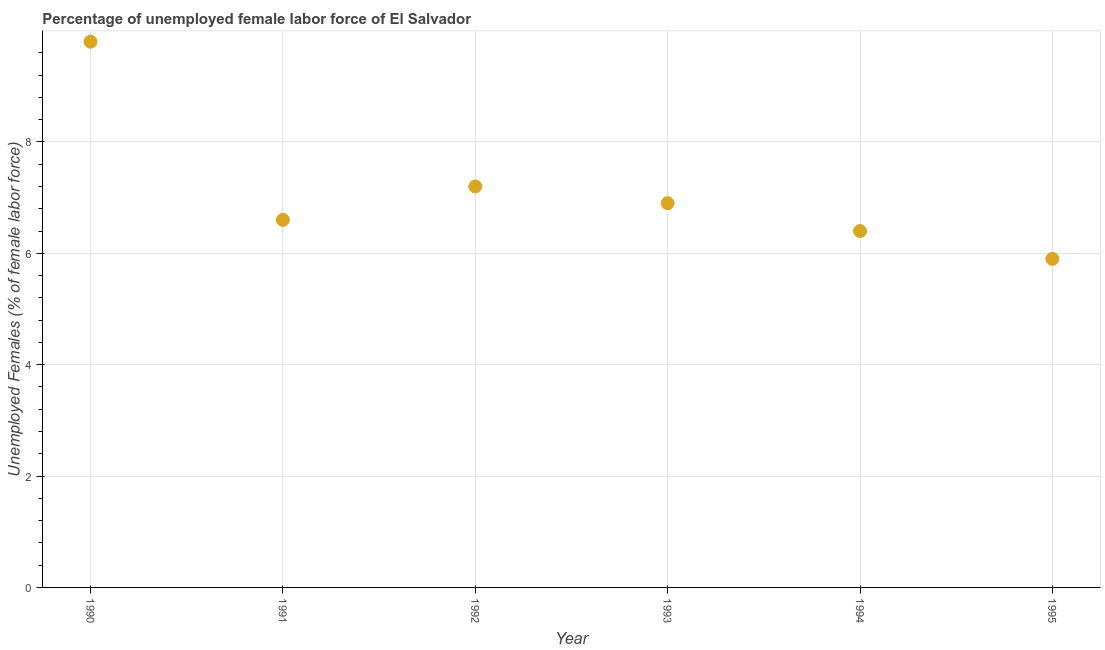What is the total unemployed female labour force in 1991?
Give a very brief answer. 6.6. Across all years, what is the maximum total unemployed female labour force?
Offer a terse response. 9.8. Across all years, what is the minimum total unemployed female labour force?
Offer a very short reply. 5.9. In which year was the total unemployed female labour force maximum?
Offer a terse response. 1990. What is the sum of the total unemployed female labour force?
Make the answer very short. 42.8. What is the difference between the total unemployed female labour force in 1990 and 1991?
Make the answer very short. 3.2. What is the average total unemployed female labour force per year?
Ensure brevity in your answer.  7.13. What is the median total unemployed female labour force?
Your answer should be compact. 6.75. In how many years, is the total unemployed female labour force greater than 4 %?
Make the answer very short. 6. Do a majority of the years between 1995 and 1992 (inclusive) have total unemployed female labour force greater than 0.4 %?
Make the answer very short. Yes. What is the ratio of the total unemployed female labour force in 1993 to that in 1995?
Give a very brief answer. 1.17. Is the total unemployed female labour force in 1992 less than that in 1994?
Keep it short and to the point. No. What is the difference between the highest and the second highest total unemployed female labour force?
Provide a succinct answer. 2.6. Is the sum of the total unemployed female labour force in 1990 and 1992 greater than the maximum total unemployed female labour force across all years?
Provide a short and direct response. Yes. What is the difference between the highest and the lowest total unemployed female labour force?
Give a very brief answer. 3.9. Does the total unemployed female labour force monotonically increase over the years?
Provide a short and direct response. No. How many years are there in the graph?
Offer a terse response. 6. Are the values on the major ticks of Y-axis written in scientific E-notation?
Offer a terse response. No. Does the graph contain any zero values?
Keep it short and to the point. No. What is the title of the graph?
Offer a very short reply. Percentage of unemployed female labor force of El Salvador. What is the label or title of the Y-axis?
Your response must be concise. Unemployed Females (% of female labor force). What is the Unemployed Females (% of female labor force) in 1990?
Your answer should be very brief. 9.8. What is the Unemployed Females (% of female labor force) in 1991?
Provide a succinct answer. 6.6. What is the Unemployed Females (% of female labor force) in 1992?
Your response must be concise. 7.2. What is the Unemployed Females (% of female labor force) in 1993?
Your response must be concise. 6.9. What is the Unemployed Females (% of female labor force) in 1994?
Provide a succinct answer. 6.4. What is the Unemployed Females (% of female labor force) in 1995?
Provide a short and direct response. 5.9. What is the difference between the Unemployed Females (% of female labor force) in 1990 and 1991?
Keep it short and to the point. 3.2. What is the difference between the Unemployed Females (% of female labor force) in 1990 and 1992?
Your answer should be compact. 2.6. What is the difference between the Unemployed Females (% of female labor force) in 1990 and 1993?
Your answer should be very brief. 2.9. What is the difference between the Unemployed Females (% of female labor force) in 1990 and 1994?
Your response must be concise. 3.4. What is the difference between the Unemployed Females (% of female labor force) in 1991 and 1994?
Offer a terse response. 0.2. What is the difference between the Unemployed Females (% of female labor force) in 1992 and 1993?
Your answer should be very brief. 0.3. What is the difference between the Unemployed Females (% of female labor force) in 1993 and 1994?
Your response must be concise. 0.5. What is the difference between the Unemployed Females (% of female labor force) in 1993 and 1995?
Your response must be concise. 1. What is the ratio of the Unemployed Females (% of female labor force) in 1990 to that in 1991?
Your answer should be compact. 1.49. What is the ratio of the Unemployed Females (% of female labor force) in 1990 to that in 1992?
Ensure brevity in your answer.  1.36. What is the ratio of the Unemployed Females (% of female labor force) in 1990 to that in 1993?
Offer a very short reply. 1.42. What is the ratio of the Unemployed Females (% of female labor force) in 1990 to that in 1994?
Keep it short and to the point. 1.53. What is the ratio of the Unemployed Females (% of female labor force) in 1990 to that in 1995?
Offer a very short reply. 1.66. What is the ratio of the Unemployed Females (% of female labor force) in 1991 to that in 1992?
Make the answer very short. 0.92. What is the ratio of the Unemployed Females (% of female labor force) in 1991 to that in 1994?
Ensure brevity in your answer.  1.03. What is the ratio of the Unemployed Females (% of female labor force) in 1991 to that in 1995?
Keep it short and to the point. 1.12. What is the ratio of the Unemployed Females (% of female labor force) in 1992 to that in 1993?
Offer a very short reply. 1.04. What is the ratio of the Unemployed Females (% of female labor force) in 1992 to that in 1994?
Make the answer very short. 1.12. What is the ratio of the Unemployed Females (% of female labor force) in 1992 to that in 1995?
Your response must be concise. 1.22. What is the ratio of the Unemployed Females (% of female labor force) in 1993 to that in 1994?
Give a very brief answer. 1.08. What is the ratio of the Unemployed Females (% of female labor force) in 1993 to that in 1995?
Ensure brevity in your answer.  1.17. What is the ratio of the Unemployed Females (% of female labor force) in 1994 to that in 1995?
Ensure brevity in your answer.  1.08. 